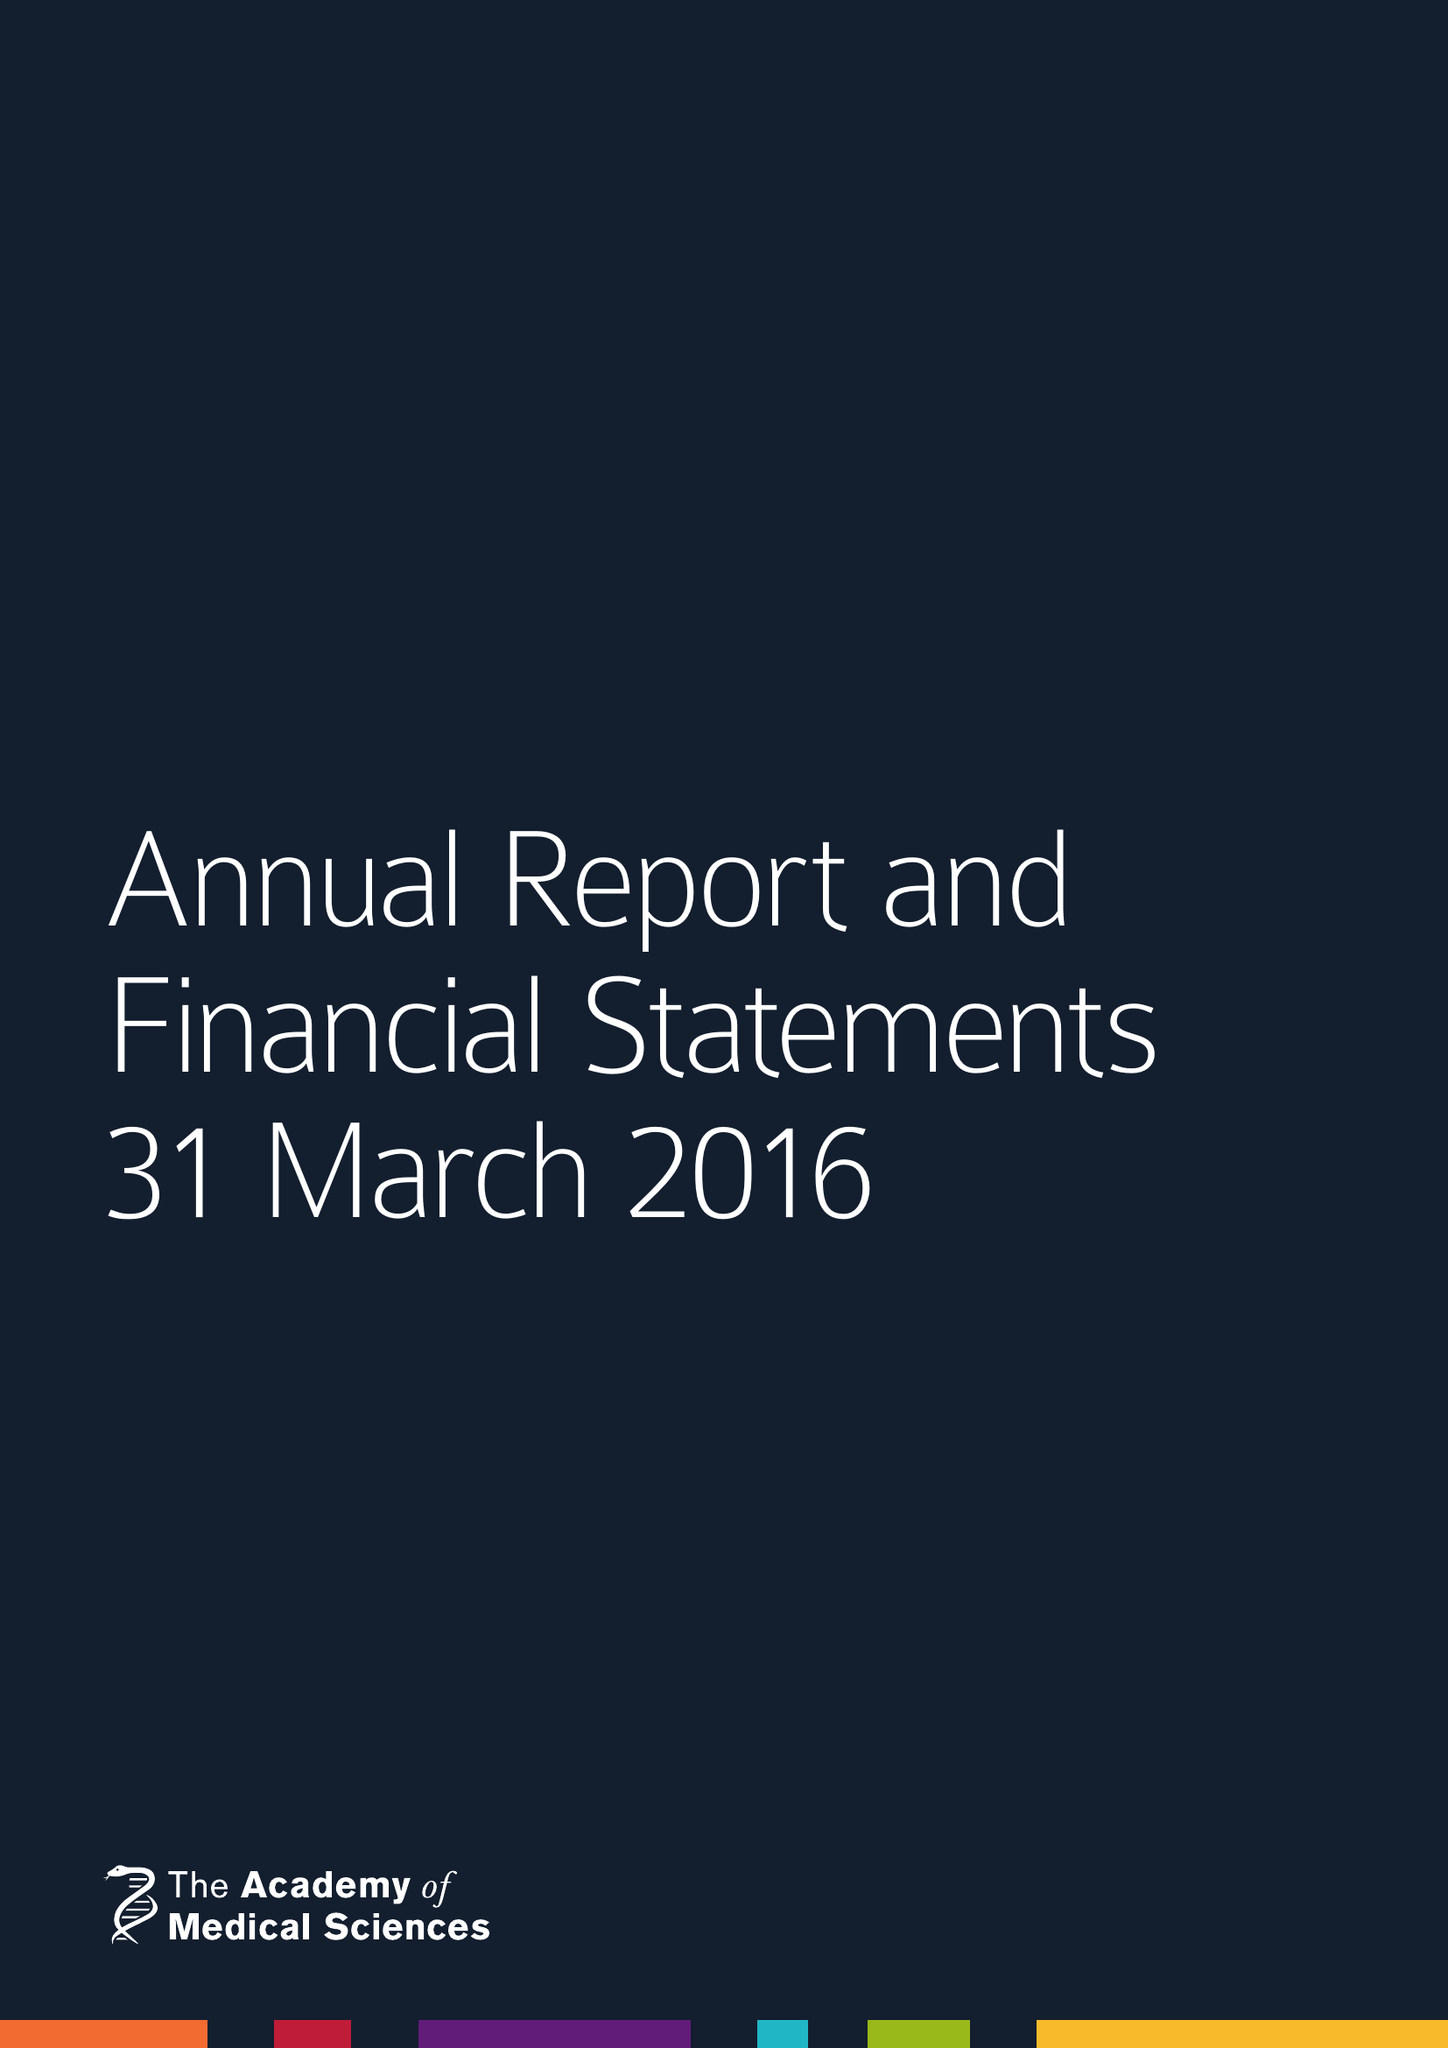What is the value for the report_date?
Answer the question using a single word or phrase. 2016-03-31 